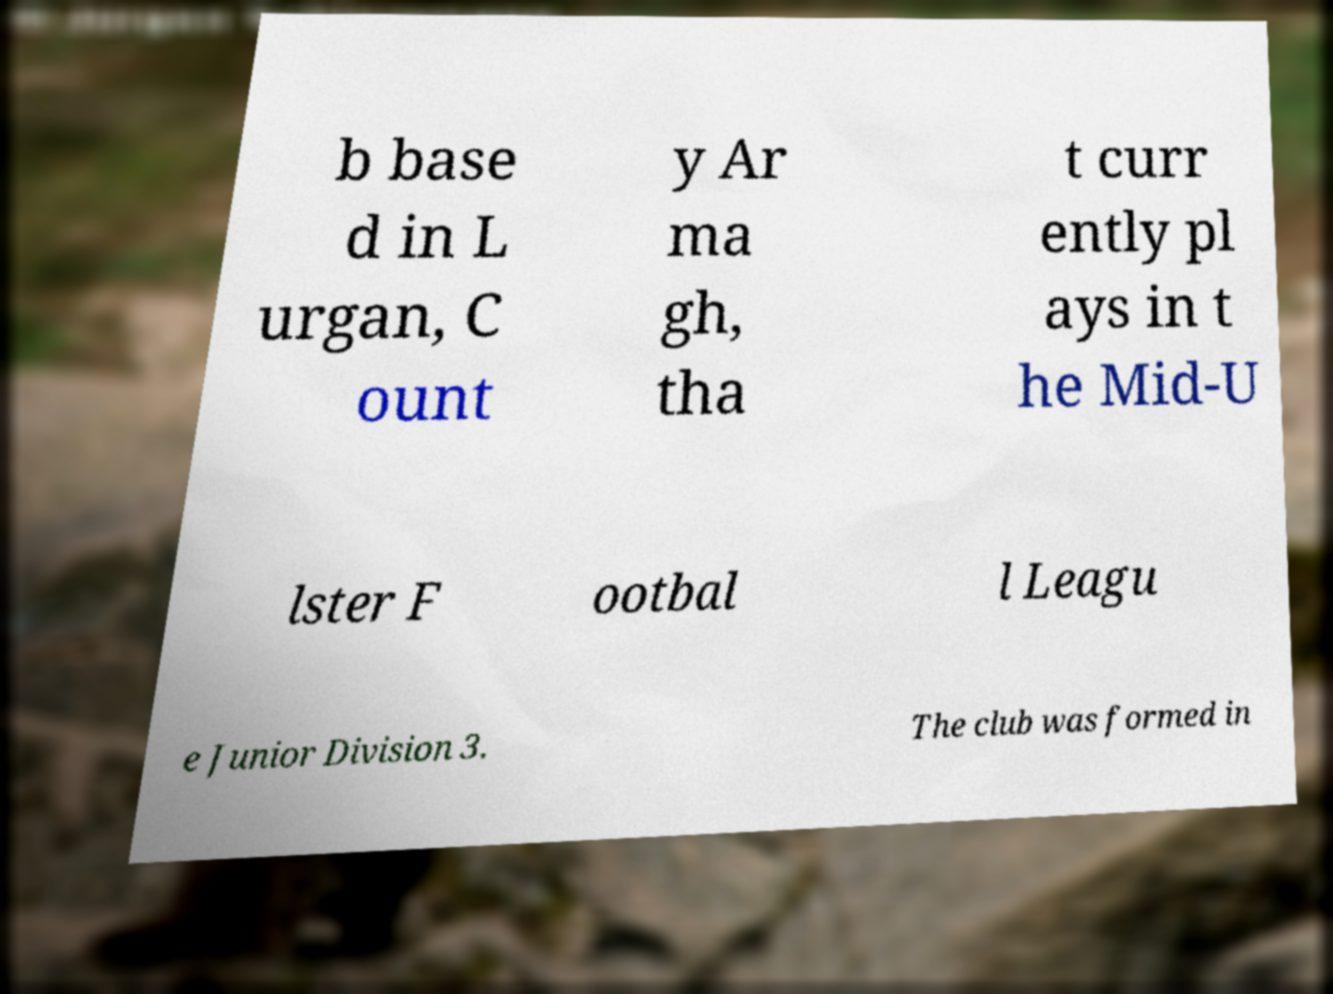There's text embedded in this image that I need extracted. Can you transcribe it verbatim? b base d in L urgan, C ount y Ar ma gh, tha t curr ently pl ays in t he Mid-U lster F ootbal l Leagu e Junior Division 3. The club was formed in 